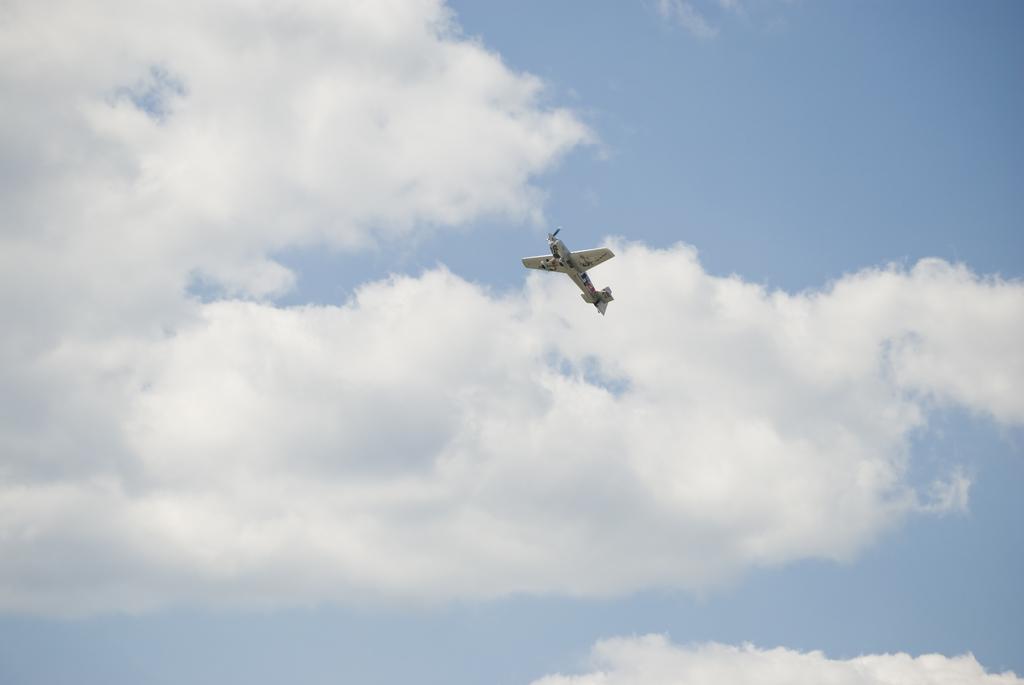In one or two sentences, can you explain what this image depicts? In this picture there is a brown color small aircraft flying in the sky. Behind there is a blue sky and white clouds. 